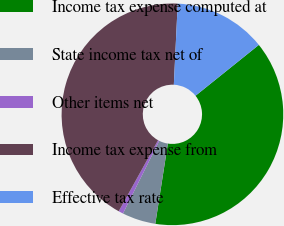<chart> <loc_0><loc_0><loc_500><loc_500><pie_chart><fcel>Income tax expense computed at<fcel>State income tax net of<fcel>Other items net<fcel>Income tax expense from<fcel>Effective tax rate<nl><fcel>38.24%<fcel>4.89%<fcel>0.69%<fcel>42.71%<fcel>13.47%<nl></chart> 